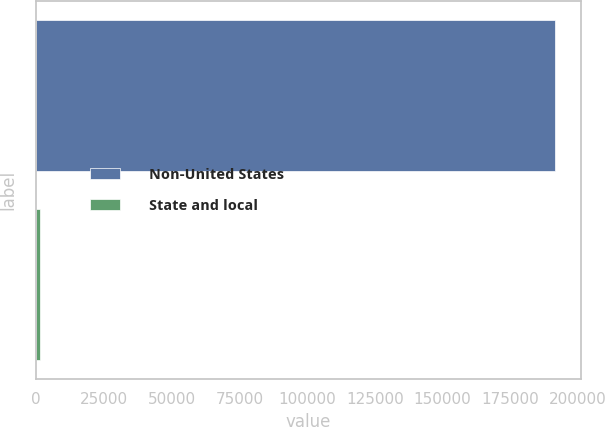<chart> <loc_0><loc_0><loc_500><loc_500><bar_chart><fcel>Non-United States<fcel>State and local<nl><fcel>191499<fcel>1331<nl></chart> 